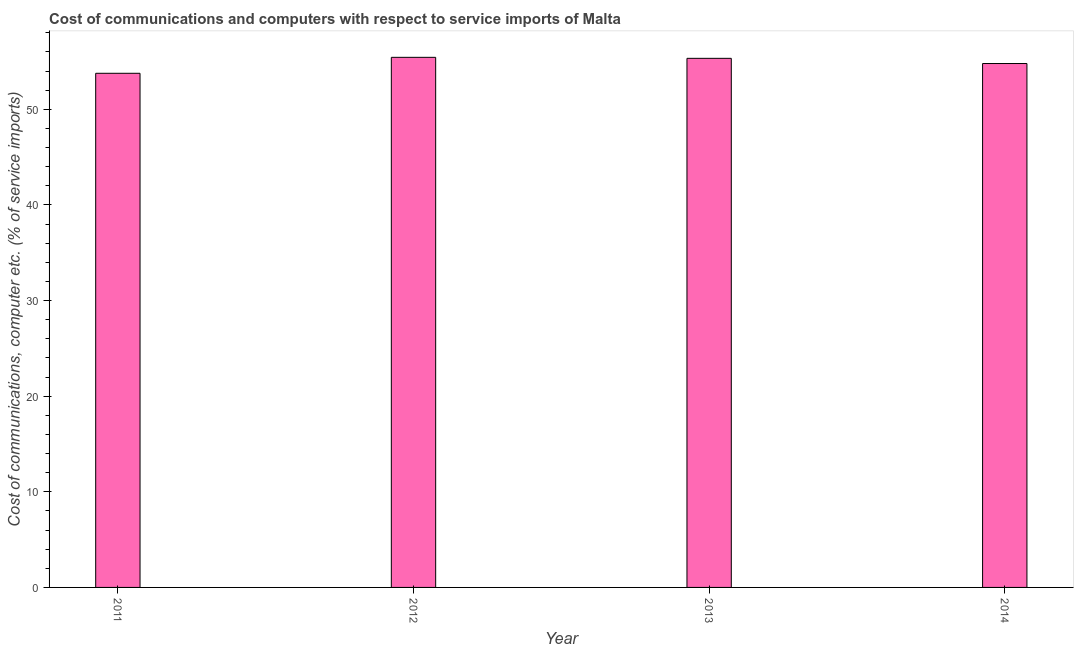Does the graph contain any zero values?
Your answer should be very brief. No. Does the graph contain grids?
Your response must be concise. No. What is the title of the graph?
Your response must be concise. Cost of communications and computers with respect to service imports of Malta. What is the label or title of the Y-axis?
Your answer should be very brief. Cost of communications, computer etc. (% of service imports). What is the cost of communications and computer in 2011?
Make the answer very short. 53.77. Across all years, what is the maximum cost of communications and computer?
Offer a very short reply. 55.44. Across all years, what is the minimum cost of communications and computer?
Ensure brevity in your answer.  53.77. In which year was the cost of communications and computer maximum?
Offer a terse response. 2012. In which year was the cost of communications and computer minimum?
Provide a succinct answer. 2011. What is the sum of the cost of communications and computer?
Offer a very short reply. 219.33. What is the difference between the cost of communications and computer in 2013 and 2014?
Provide a succinct answer. 0.54. What is the average cost of communications and computer per year?
Provide a short and direct response. 54.83. What is the median cost of communications and computer?
Your response must be concise. 55.06. In how many years, is the cost of communications and computer greater than 54 %?
Give a very brief answer. 3. Do a majority of the years between 2014 and 2013 (inclusive) have cost of communications and computer greater than 54 %?
Make the answer very short. No. What is the ratio of the cost of communications and computer in 2012 to that in 2013?
Your answer should be compact. 1. Is the difference between the cost of communications and computer in 2011 and 2012 greater than the difference between any two years?
Offer a terse response. Yes. What is the difference between the highest and the second highest cost of communications and computer?
Your response must be concise. 0.1. Is the sum of the cost of communications and computer in 2013 and 2014 greater than the maximum cost of communications and computer across all years?
Ensure brevity in your answer.  Yes. What is the difference between the highest and the lowest cost of communications and computer?
Provide a succinct answer. 1.67. In how many years, is the cost of communications and computer greater than the average cost of communications and computer taken over all years?
Offer a very short reply. 2. Are all the bars in the graph horizontal?
Offer a terse response. No. Are the values on the major ticks of Y-axis written in scientific E-notation?
Give a very brief answer. No. What is the Cost of communications, computer etc. (% of service imports) in 2011?
Give a very brief answer. 53.77. What is the Cost of communications, computer etc. (% of service imports) in 2012?
Your answer should be compact. 55.44. What is the Cost of communications, computer etc. (% of service imports) in 2013?
Your answer should be compact. 55.33. What is the Cost of communications, computer etc. (% of service imports) in 2014?
Give a very brief answer. 54.79. What is the difference between the Cost of communications, computer etc. (% of service imports) in 2011 and 2012?
Your answer should be compact. -1.67. What is the difference between the Cost of communications, computer etc. (% of service imports) in 2011 and 2013?
Ensure brevity in your answer.  -1.56. What is the difference between the Cost of communications, computer etc. (% of service imports) in 2011 and 2014?
Give a very brief answer. -1.02. What is the difference between the Cost of communications, computer etc. (% of service imports) in 2012 and 2013?
Give a very brief answer. 0.11. What is the difference between the Cost of communications, computer etc. (% of service imports) in 2012 and 2014?
Ensure brevity in your answer.  0.65. What is the difference between the Cost of communications, computer etc. (% of service imports) in 2013 and 2014?
Keep it short and to the point. 0.54. What is the ratio of the Cost of communications, computer etc. (% of service imports) in 2011 to that in 2012?
Make the answer very short. 0.97. What is the ratio of the Cost of communications, computer etc. (% of service imports) in 2011 to that in 2014?
Offer a terse response. 0.98. What is the ratio of the Cost of communications, computer etc. (% of service imports) in 2012 to that in 2013?
Provide a succinct answer. 1. 